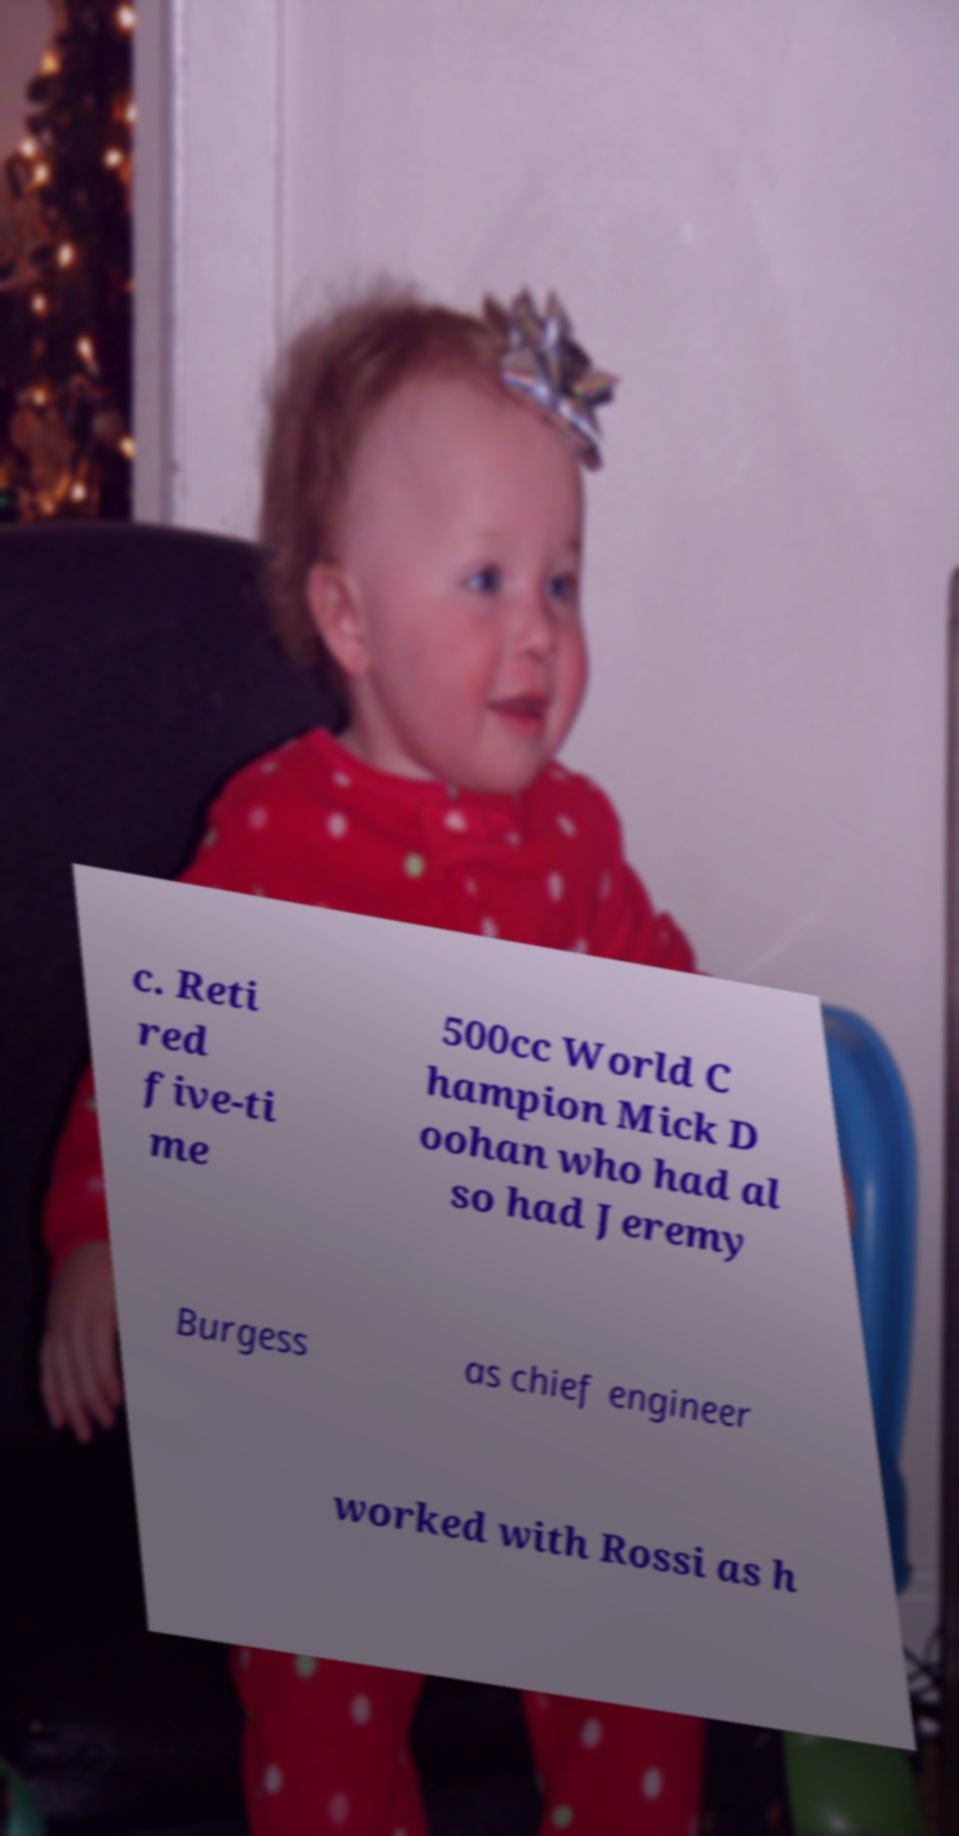Could you assist in decoding the text presented in this image and type it out clearly? c. Reti red five-ti me 500cc World C hampion Mick D oohan who had al so had Jeremy Burgess as chief engineer worked with Rossi as h 